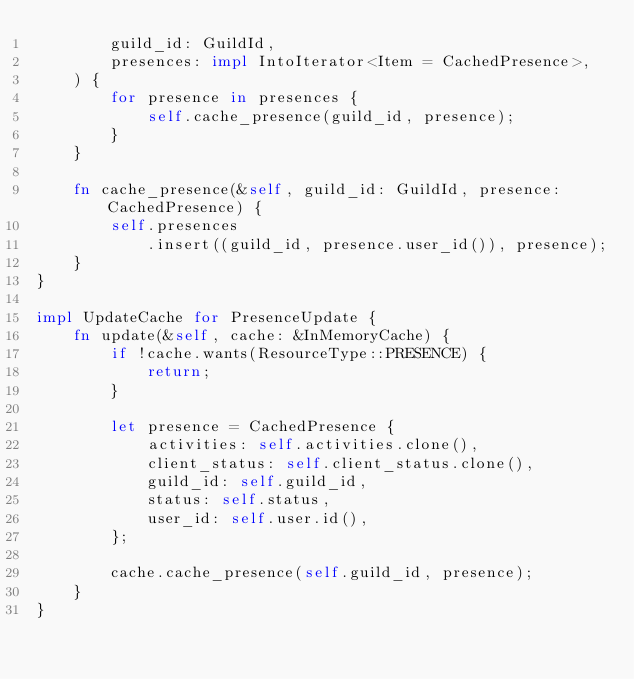Convert code to text. <code><loc_0><loc_0><loc_500><loc_500><_Rust_>        guild_id: GuildId,
        presences: impl IntoIterator<Item = CachedPresence>,
    ) {
        for presence in presences {
            self.cache_presence(guild_id, presence);
        }
    }

    fn cache_presence(&self, guild_id: GuildId, presence: CachedPresence) {
        self.presences
            .insert((guild_id, presence.user_id()), presence);
    }
}

impl UpdateCache for PresenceUpdate {
    fn update(&self, cache: &InMemoryCache) {
        if !cache.wants(ResourceType::PRESENCE) {
            return;
        }

        let presence = CachedPresence {
            activities: self.activities.clone(),
            client_status: self.client_status.clone(),
            guild_id: self.guild_id,
            status: self.status,
            user_id: self.user.id(),
        };

        cache.cache_presence(self.guild_id, presence);
    }
}
</code> 